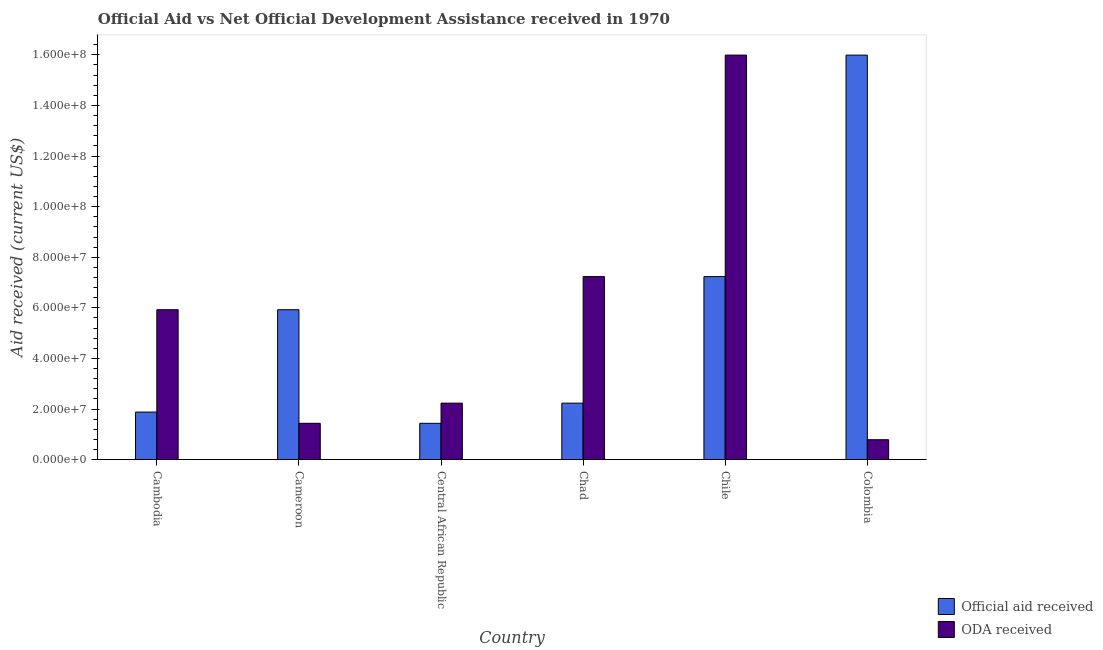How many different coloured bars are there?
Provide a short and direct response. 2. Are the number of bars per tick equal to the number of legend labels?
Keep it short and to the point. Yes. What is the official aid received in Colombia?
Your answer should be compact. 1.60e+08. Across all countries, what is the maximum oda received?
Your response must be concise. 1.60e+08. Across all countries, what is the minimum oda received?
Your response must be concise. 7.89e+06. In which country was the official aid received maximum?
Give a very brief answer. Colombia. In which country was the official aid received minimum?
Your answer should be very brief. Central African Republic. What is the total oda received in the graph?
Provide a short and direct response. 3.36e+08. What is the difference between the oda received in Central African Republic and that in Chile?
Give a very brief answer. -1.38e+08. What is the difference between the oda received in Chile and the official aid received in Central African Republic?
Keep it short and to the point. 1.46e+08. What is the average oda received per country?
Make the answer very short. 5.60e+07. What is the difference between the oda received and official aid received in Chile?
Provide a succinct answer. 8.75e+07. In how many countries, is the oda received greater than 68000000 US$?
Your answer should be very brief. 2. What is the ratio of the oda received in Cambodia to that in Colombia?
Your answer should be very brief. 7.51. Is the oda received in Cambodia less than that in Colombia?
Ensure brevity in your answer.  No. What is the difference between the highest and the second highest official aid received?
Give a very brief answer. 8.75e+07. What is the difference between the highest and the lowest oda received?
Your response must be concise. 1.52e+08. In how many countries, is the oda received greater than the average oda received taken over all countries?
Offer a very short reply. 3. What does the 2nd bar from the left in Central African Republic represents?
Offer a terse response. ODA received. What does the 2nd bar from the right in Colombia represents?
Provide a short and direct response. Official aid received. How many countries are there in the graph?
Provide a succinct answer. 6. What is the difference between two consecutive major ticks on the Y-axis?
Your response must be concise. 2.00e+07. Are the values on the major ticks of Y-axis written in scientific E-notation?
Your response must be concise. Yes. Does the graph contain any zero values?
Offer a very short reply. No. Where does the legend appear in the graph?
Your answer should be compact. Bottom right. How many legend labels are there?
Offer a very short reply. 2. How are the legend labels stacked?
Provide a short and direct response. Vertical. What is the title of the graph?
Provide a succinct answer. Official Aid vs Net Official Development Assistance received in 1970 . Does "International Visitors" appear as one of the legend labels in the graph?
Give a very brief answer. No. What is the label or title of the X-axis?
Your response must be concise. Country. What is the label or title of the Y-axis?
Offer a terse response. Aid received (current US$). What is the Aid received (current US$) of Official aid received in Cambodia?
Ensure brevity in your answer.  1.88e+07. What is the Aid received (current US$) in ODA received in Cambodia?
Make the answer very short. 5.93e+07. What is the Aid received (current US$) of Official aid received in Cameroon?
Ensure brevity in your answer.  5.93e+07. What is the Aid received (current US$) in ODA received in Cameroon?
Provide a succinct answer. 1.44e+07. What is the Aid received (current US$) in Official aid received in Central African Republic?
Your answer should be very brief. 1.44e+07. What is the Aid received (current US$) in ODA received in Central African Republic?
Ensure brevity in your answer.  2.24e+07. What is the Aid received (current US$) in Official aid received in Chad?
Provide a succinct answer. 2.24e+07. What is the Aid received (current US$) of ODA received in Chad?
Ensure brevity in your answer.  7.24e+07. What is the Aid received (current US$) of Official aid received in Chile?
Your answer should be very brief. 7.24e+07. What is the Aid received (current US$) of ODA received in Chile?
Provide a short and direct response. 1.60e+08. What is the Aid received (current US$) of Official aid received in Colombia?
Your answer should be compact. 1.60e+08. What is the Aid received (current US$) in ODA received in Colombia?
Your answer should be compact. 7.89e+06. Across all countries, what is the maximum Aid received (current US$) in Official aid received?
Ensure brevity in your answer.  1.60e+08. Across all countries, what is the maximum Aid received (current US$) in ODA received?
Your response must be concise. 1.60e+08. Across all countries, what is the minimum Aid received (current US$) of Official aid received?
Offer a terse response. 1.44e+07. Across all countries, what is the minimum Aid received (current US$) in ODA received?
Your answer should be compact. 7.89e+06. What is the total Aid received (current US$) in Official aid received in the graph?
Ensure brevity in your answer.  3.47e+08. What is the total Aid received (current US$) in ODA received in the graph?
Offer a very short reply. 3.36e+08. What is the difference between the Aid received (current US$) of Official aid received in Cambodia and that in Cameroon?
Make the answer very short. -4.04e+07. What is the difference between the Aid received (current US$) of ODA received in Cambodia and that in Cameroon?
Offer a terse response. 4.49e+07. What is the difference between the Aid received (current US$) of Official aid received in Cambodia and that in Central African Republic?
Your answer should be compact. 4.45e+06. What is the difference between the Aid received (current US$) of ODA received in Cambodia and that in Central African Republic?
Give a very brief answer. 3.69e+07. What is the difference between the Aid received (current US$) in Official aid received in Cambodia and that in Chad?
Give a very brief answer. -3.52e+06. What is the difference between the Aid received (current US$) of ODA received in Cambodia and that in Chad?
Give a very brief answer. -1.31e+07. What is the difference between the Aid received (current US$) of Official aid received in Cambodia and that in Chile?
Your response must be concise. -5.35e+07. What is the difference between the Aid received (current US$) in ODA received in Cambodia and that in Chile?
Your answer should be compact. -1.01e+08. What is the difference between the Aid received (current US$) in Official aid received in Cambodia and that in Colombia?
Your response must be concise. -1.41e+08. What is the difference between the Aid received (current US$) of ODA received in Cambodia and that in Colombia?
Keep it short and to the point. 5.14e+07. What is the difference between the Aid received (current US$) in Official aid received in Cameroon and that in Central African Republic?
Make the answer very short. 4.49e+07. What is the difference between the Aid received (current US$) of ODA received in Cameroon and that in Central African Republic?
Give a very brief answer. -7.97e+06. What is the difference between the Aid received (current US$) of Official aid received in Cameroon and that in Chad?
Offer a very short reply. 3.69e+07. What is the difference between the Aid received (current US$) in ODA received in Cameroon and that in Chad?
Give a very brief answer. -5.80e+07. What is the difference between the Aid received (current US$) of Official aid received in Cameroon and that in Chile?
Your response must be concise. -1.31e+07. What is the difference between the Aid received (current US$) in ODA received in Cameroon and that in Chile?
Offer a terse response. -1.46e+08. What is the difference between the Aid received (current US$) of Official aid received in Cameroon and that in Colombia?
Make the answer very short. -1.01e+08. What is the difference between the Aid received (current US$) of ODA received in Cameroon and that in Colombia?
Your answer should be very brief. 6.49e+06. What is the difference between the Aid received (current US$) in Official aid received in Central African Republic and that in Chad?
Your answer should be very brief. -7.97e+06. What is the difference between the Aid received (current US$) in ODA received in Central African Republic and that in Chad?
Give a very brief answer. -5.00e+07. What is the difference between the Aid received (current US$) in Official aid received in Central African Republic and that in Chile?
Give a very brief answer. -5.80e+07. What is the difference between the Aid received (current US$) of ODA received in Central African Republic and that in Chile?
Your response must be concise. -1.38e+08. What is the difference between the Aid received (current US$) in Official aid received in Central African Republic and that in Colombia?
Your response must be concise. -1.46e+08. What is the difference between the Aid received (current US$) of ODA received in Central African Republic and that in Colombia?
Provide a short and direct response. 1.45e+07. What is the difference between the Aid received (current US$) in Official aid received in Chad and that in Chile?
Ensure brevity in your answer.  -5.00e+07. What is the difference between the Aid received (current US$) in ODA received in Chad and that in Chile?
Give a very brief answer. -8.75e+07. What is the difference between the Aid received (current US$) in Official aid received in Chad and that in Colombia?
Give a very brief answer. -1.38e+08. What is the difference between the Aid received (current US$) in ODA received in Chad and that in Colombia?
Offer a very short reply. 6.45e+07. What is the difference between the Aid received (current US$) of Official aid received in Chile and that in Colombia?
Ensure brevity in your answer.  -8.75e+07. What is the difference between the Aid received (current US$) of ODA received in Chile and that in Colombia?
Keep it short and to the point. 1.52e+08. What is the difference between the Aid received (current US$) in Official aid received in Cambodia and the Aid received (current US$) in ODA received in Cameroon?
Your answer should be compact. 4.45e+06. What is the difference between the Aid received (current US$) in Official aid received in Cambodia and the Aid received (current US$) in ODA received in Central African Republic?
Make the answer very short. -3.52e+06. What is the difference between the Aid received (current US$) in Official aid received in Cambodia and the Aid received (current US$) in ODA received in Chad?
Your answer should be very brief. -5.35e+07. What is the difference between the Aid received (current US$) of Official aid received in Cambodia and the Aid received (current US$) of ODA received in Chile?
Your answer should be very brief. -1.41e+08. What is the difference between the Aid received (current US$) of Official aid received in Cambodia and the Aid received (current US$) of ODA received in Colombia?
Give a very brief answer. 1.09e+07. What is the difference between the Aid received (current US$) of Official aid received in Cameroon and the Aid received (current US$) of ODA received in Central African Republic?
Give a very brief answer. 3.69e+07. What is the difference between the Aid received (current US$) in Official aid received in Cameroon and the Aid received (current US$) in ODA received in Chad?
Provide a succinct answer. -1.31e+07. What is the difference between the Aid received (current US$) of Official aid received in Cameroon and the Aid received (current US$) of ODA received in Chile?
Keep it short and to the point. -1.01e+08. What is the difference between the Aid received (current US$) of Official aid received in Cameroon and the Aid received (current US$) of ODA received in Colombia?
Ensure brevity in your answer.  5.14e+07. What is the difference between the Aid received (current US$) of Official aid received in Central African Republic and the Aid received (current US$) of ODA received in Chad?
Offer a very short reply. -5.80e+07. What is the difference between the Aid received (current US$) in Official aid received in Central African Republic and the Aid received (current US$) in ODA received in Chile?
Give a very brief answer. -1.46e+08. What is the difference between the Aid received (current US$) of Official aid received in Central African Republic and the Aid received (current US$) of ODA received in Colombia?
Give a very brief answer. 6.49e+06. What is the difference between the Aid received (current US$) in Official aid received in Chad and the Aid received (current US$) in ODA received in Chile?
Give a very brief answer. -1.38e+08. What is the difference between the Aid received (current US$) of Official aid received in Chad and the Aid received (current US$) of ODA received in Colombia?
Your response must be concise. 1.45e+07. What is the difference between the Aid received (current US$) of Official aid received in Chile and the Aid received (current US$) of ODA received in Colombia?
Provide a short and direct response. 6.45e+07. What is the average Aid received (current US$) in Official aid received per country?
Your answer should be very brief. 5.78e+07. What is the average Aid received (current US$) of ODA received per country?
Make the answer very short. 5.60e+07. What is the difference between the Aid received (current US$) of Official aid received and Aid received (current US$) of ODA received in Cambodia?
Offer a terse response. -4.04e+07. What is the difference between the Aid received (current US$) of Official aid received and Aid received (current US$) of ODA received in Cameroon?
Provide a succinct answer. 4.49e+07. What is the difference between the Aid received (current US$) of Official aid received and Aid received (current US$) of ODA received in Central African Republic?
Your response must be concise. -7.97e+06. What is the difference between the Aid received (current US$) of Official aid received and Aid received (current US$) of ODA received in Chad?
Keep it short and to the point. -5.00e+07. What is the difference between the Aid received (current US$) in Official aid received and Aid received (current US$) in ODA received in Chile?
Give a very brief answer. -8.75e+07. What is the difference between the Aid received (current US$) of Official aid received and Aid received (current US$) of ODA received in Colombia?
Keep it short and to the point. 1.52e+08. What is the ratio of the Aid received (current US$) in Official aid received in Cambodia to that in Cameroon?
Make the answer very short. 0.32. What is the ratio of the Aid received (current US$) of ODA received in Cambodia to that in Cameroon?
Give a very brief answer. 4.12. What is the ratio of the Aid received (current US$) in Official aid received in Cambodia to that in Central African Republic?
Keep it short and to the point. 1.31. What is the ratio of the Aid received (current US$) in ODA received in Cambodia to that in Central African Republic?
Offer a terse response. 2.65. What is the ratio of the Aid received (current US$) of Official aid received in Cambodia to that in Chad?
Provide a succinct answer. 0.84. What is the ratio of the Aid received (current US$) of ODA received in Cambodia to that in Chad?
Your response must be concise. 0.82. What is the ratio of the Aid received (current US$) in Official aid received in Cambodia to that in Chile?
Ensure brevity in your answer.  0.26. What is the ratio of the Aid received (current US$) in ODA received in Cambodia to that in Chile?
Provide a succinct answer. 0.37. What is the ratio of the Aid received (current US$) of Official aid received in Cambodia to that in Colombia?
Offer a very short reply. 0.12. What is the ratio of the Aid received (current US$) of ODA received in Cambodia to that in Colombia?
Offer a terse response. 7.51. What is the ratio of the Aid received (current US$) of Official aid received in Cameroon to that in Central African Republic?
Make the answer very short. 4.12. What is the ratio of the Aid received (current US$) of ODA received in Cameroon to that in Central African Republic?
Your response must be concise. 0.64. What is the ratio of the Aid received (current US$) of Official aid received in Cameroon to that in Chad?
Your answer should be compact. 2.65. What is the ratio of the Aid received (current US$) in ODA received in Cameroon to that in Chad?
Offer a very short reply. 0.2. What is the ratio of the Aid received (current US$) in Official aid received in Cameroon to that in Chile?
Provide a short and direct response. 0.82. What is the ratio of the Aid received (current US$) in ODA received in Cameroon to that in Chile?
Provide a short and direct response. 0.09. What is the ratio of the Aid received (current US$) of Official aid received in Cameroon to that in Colombia?
Offer a very short reply. 0.37. What is the ratio of the Aid received (current US$) in ODA received in Cameroon to that in Colombia?
Ensure brevity in your answer.  1.82. What is the ratio of the Aid received (current US$) in Official aid received in Central African Republic to that in Chad?
Give a very brief answer. 0.64. What is the ratio of the Aid received (current US$) in ODA received in Central African Republic to that in Chad?
Ensure brevity in your answer.  0.31. What is the ratio of the Aid received (current US$) of Official aid received in Central African Republic to that in Chile?
Offer a very short reply. 0.2. What is the ratio of the Aid received (current US$) in ODA received in Central African Republic to that in Chile?
Ensure brevity in your answer.  0.14. What is the ratio of the Aid received (current US$) of Official aid received in Central African Republic to that in Colombia?
Provide a short and direct response. 0.09. What is the ratio of the Aid received (current US$) in ODA received in Central African Republic to that in Colombia?
Ensure brevity in your answer.  2.83. What is the ratio of the Aid received (current US$) in Official aid received in Chad to that in Chile?
Provide a short and direct response. 0.31. What is the ratio of the Aid received (current US$) in ODA received in Chad to that in Chile?
Ensure brevity in your answer.  0.45. What is the ratio of the Aid received (current US$) in Official aid received in Chad to that in Colombia?
Ensure brevity in your answer.  0.14. What is the ratio of the Aid received (current US$) of ODA received in Chad to that in Colombia?
Your response must be concise. 9.17. What is the ratio of the Aid received (current US$) in Official aid received in Chile to that in Colombia?
Offer a terse response. 0.45. What is the ratio of the Aid received (current US$) of ODA received in Chile to that in Colombia?
Make the answer very short. 20.26. What is the difference between the highest and the second highest Aid received (current US$) of Official aid received?
Offer a very short reply. 8.75e+07. What is the difference between the highest and the second highest Aid received (current US$) in ODA received?
Give a very brief answer. 8.75e+07. What is the difference between the highest and the lowest Aid received (current US$) of Official aid received?
Your answer should be compact. 1.46e+08. What is the difference between the highest and the lowest Aid received (current US$) in ODA received?
Give a very brief answer. 1.52e+08. 